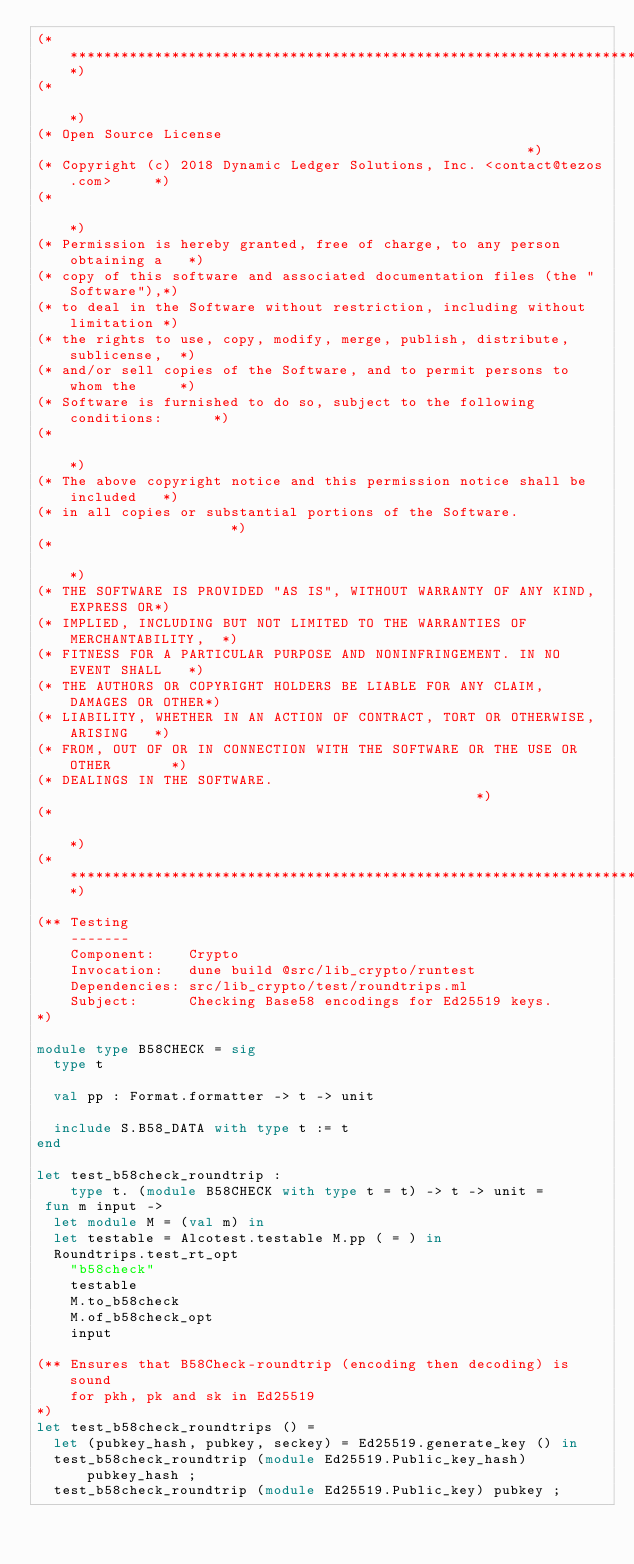<code> <loc_0><loc_0><loc_500><loc_500><_OCaml_>(*****************************************************************************)
(*                                                                           *)
(* Open Source License                                                       *)
(* Copyright (c) 2018 Dynamic Ledger Solutions, Inc. <contact@tezos.com>     *)
(*                                                                           *)
(* Permission is hereby granted, free of charge, to any person obtaining a   *)
(* copy of this software and associated documentation files (the "Software"),*)
(* to deal in the Software without restriction, including without limitation *)
(* the rights to use, copy, modify, merge, publish, distribute, sublicense,  *)
(* and/or sell copies of the Software, and to permit persons to whom the     *)
(* Software is furnished to do so, subject to the following conditions:      *)
(*                                                                           *)
(* The above copyright notice and this permission notice shall be included   *)
(* in all copies or substantial portions of the Software.                    *)
(*                                                                           *)
(* THE SOFTWARE IS PROVIDED "AS IS", WITHOUT WARRANTY OF ANY KIND, EXPRESS OR*)
(* IMPLIED, INCLUDING BUT NOT LIMITED TO THE WARRANTIES OF MERCHANTABILITY,  *)
(* FITNESS FOR A PARTICULAR PURPOSE AND NONINFRINGEMENT. IN NO EVENT SHALL   *)
(* THE AUTHORS OR COPYRIGHT HOLDERS BE LIABLE FOR ANY CLAIM, DAMAGES OR OTHER*)
(* LIABILITY, WHETHER IN AN ACTION OF CONTRACT, TORT OR OTHERWISE, ARISING   *)
(* FROM, OUT OF OR IN CONNECTION WITH THE SOFTWARE OR THE USE OR OTHER       *)
(* DEALINGS IN THE SOFTWARE.                                                 *)
(*                                                                           *)
(*****************************************************************************)

(** Testing
    -------
    Component:    Crypto
    Invocation:   dune build @src/lib_crypto/runtest
    Dependencies: src/lib_crypto/test/roundtrips.ml
    Subject:      Checking Base58 encodings for Ed25519 keys.
*)

module type B58CHECK = sig
  type t

  val pp : Format.formatter -> t -> unit

  include S.B58_DATA with type t := t
end

let test_b58check_roundtrip :
    type t. (module B58CHECK with type t = t) -> t -> unit =
 fun m input ->
  let module M = (val m) in
  let testable = Alcotest.testable M.pp ( = ) in
  Roundtrips.test_rt_opt
    "b58check"
    testable
    M.to_b58check
    M.of_b58check_opt
    input

(** Ensures that B58Check-roundtrip (encoding then decoding) is sound
    for pkh, pk and sk in Ed25519
*)
let test_b58check_roundtrips () =
  let (pubkey_hash, pubkey, seckey) = Ed25519.generate_key () in
  test_b58check_roundtrip (module Ed25519.Public_key_hash) pubkey_hash ;
  test_b58check_roundtrip (module Ed25519.Public_key) pubkey ;</code> 